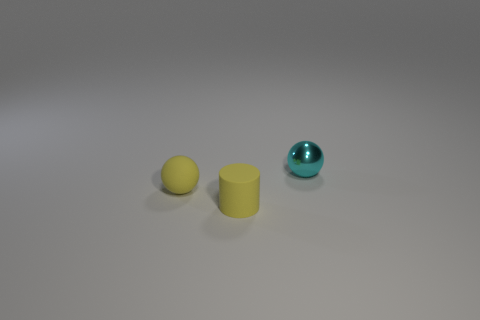Add 3 yellow rubber balls. How many objects exist? 6 Subtract all spheres. How many objects are left? 1 Add 2 tiny red rubber cylinders. How many tiny red rubber cylinders exist? 2 Subtract 1 yellow balls. How many objects are left? 2 Subtract all tiny cyan things. Subtract all yellow objects. How many objects are left? 0 Add 3 tiny rubber spheres. How many tiny rubber spheres are left? 4 